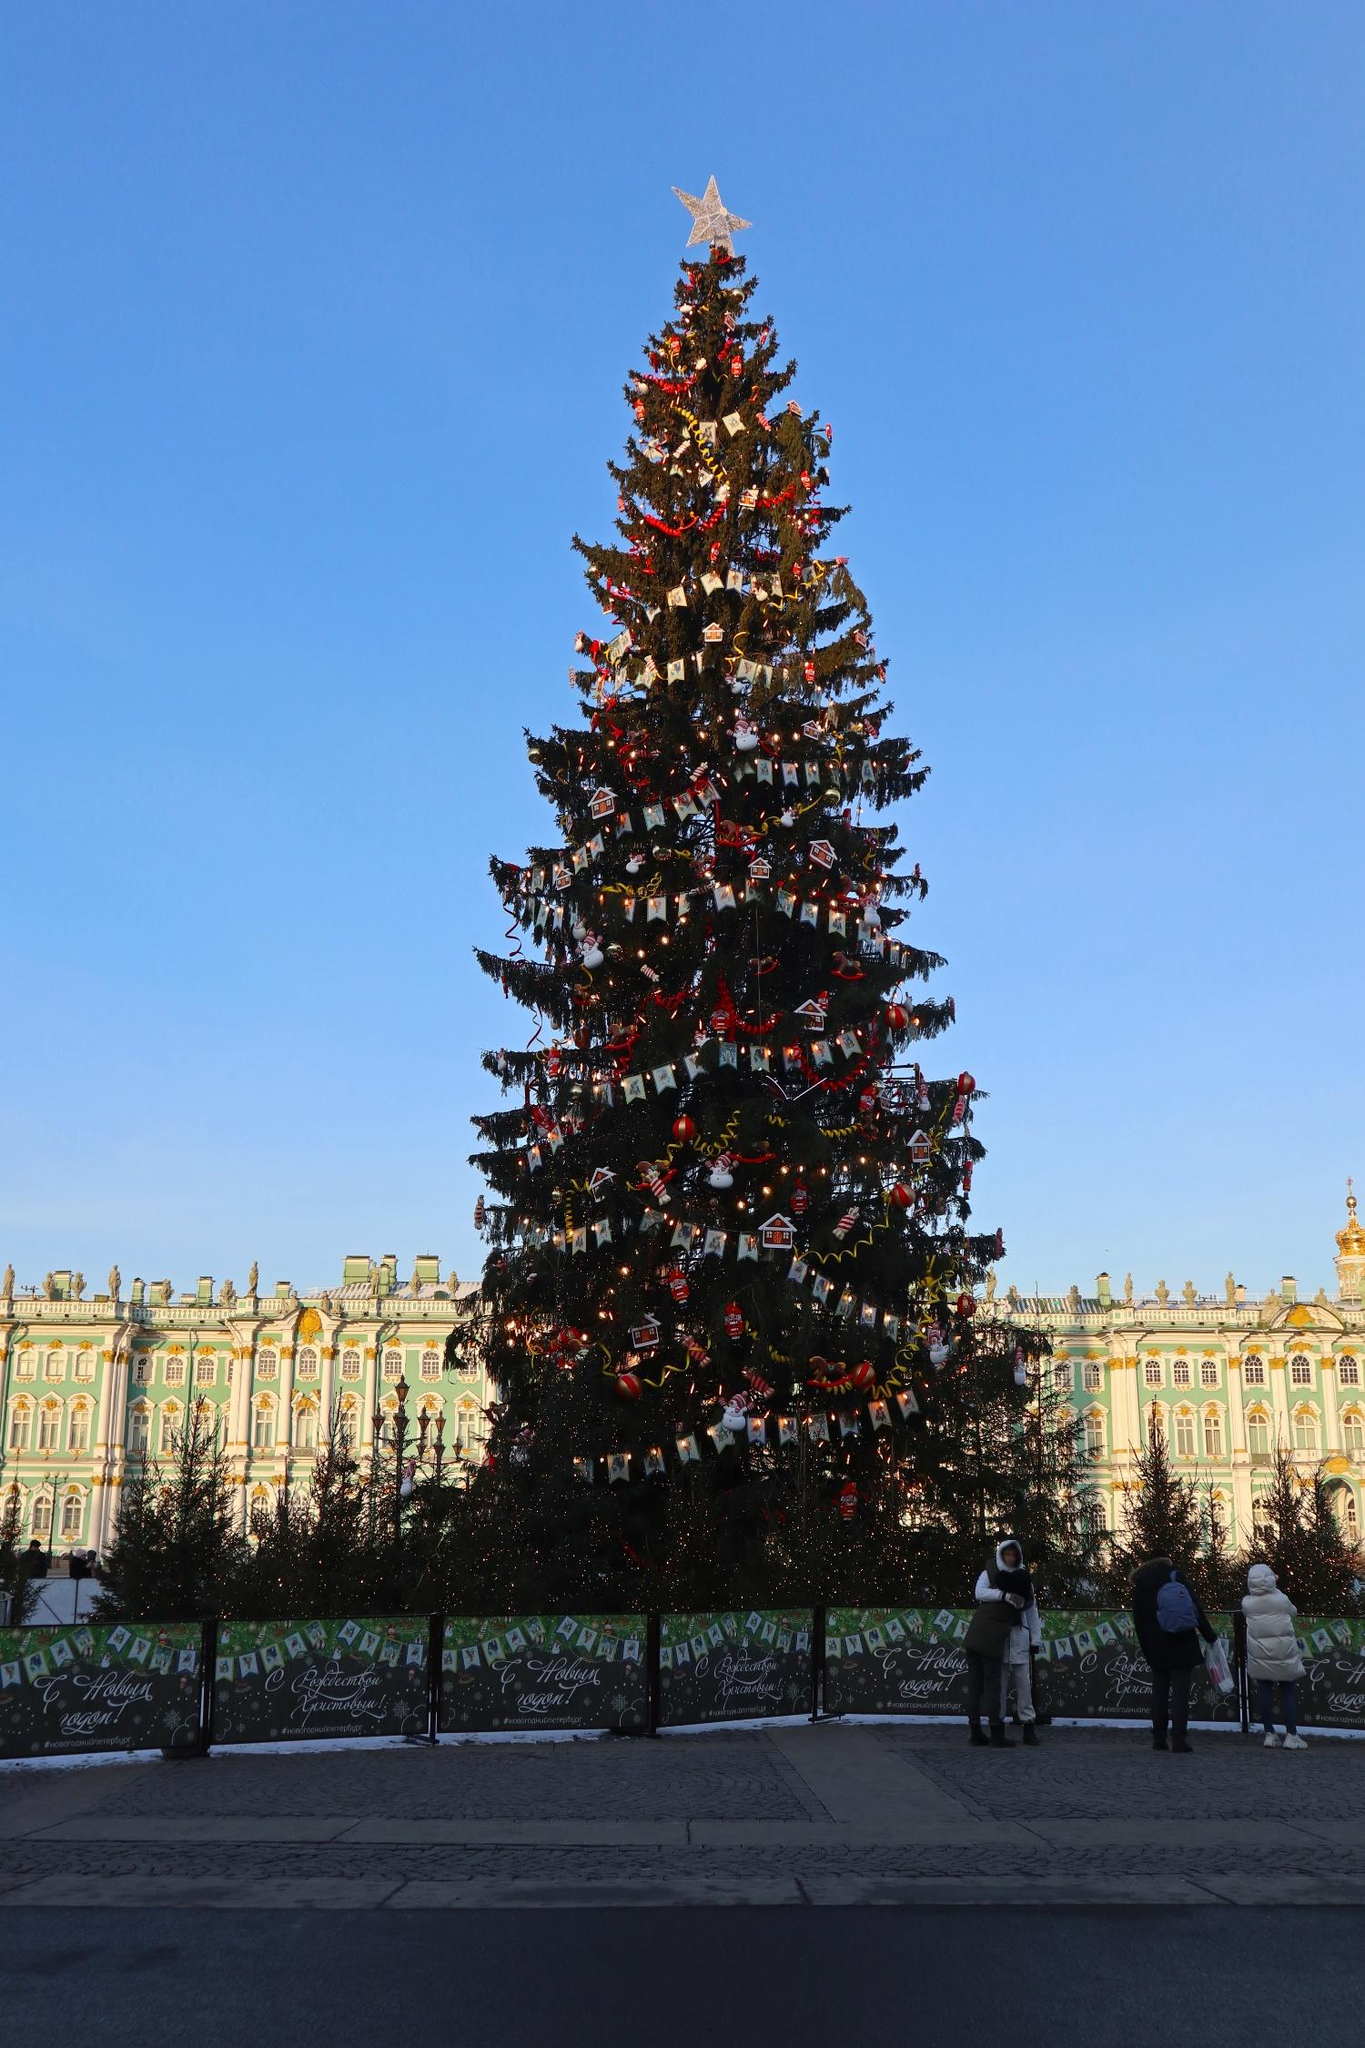What makes this tree special compared to others? This Christmas tree stands out due to its impressive size and the intricate decorations that adorn it. The tree is not just decorated with typical ornaments but also features various miniature houses and figurines, giving it a unique and personalized touch. The large gold star at the top adds a majestic finish. Additionally, the backdrop of the ornate, green-roofed building enhances the overall grandeur of the scene, making this tree a centerpiece of holiday celebration. 